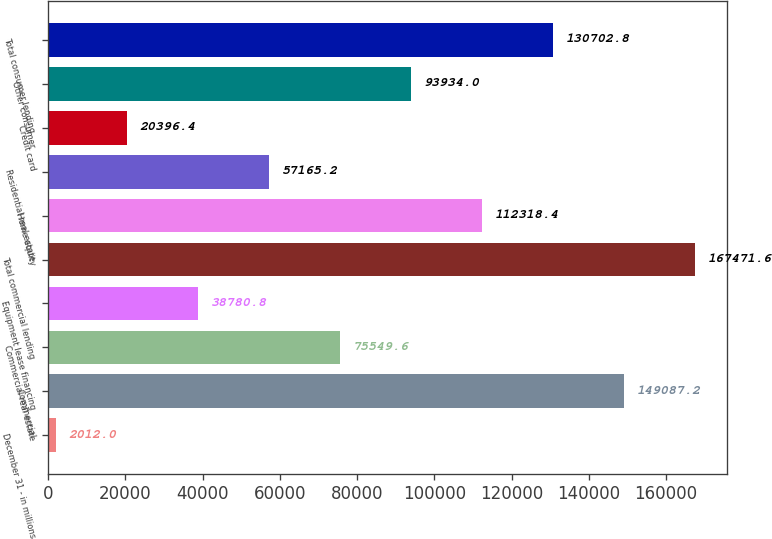<chart> <loc_0><loc_0><loc_500><loc_500><bar_chart><fcel>December 31 - in millions<fcel>Commercial<fcel>Commercial real estate<fcel>Equipment lease financing<fcel>Total commercial lending<fcel>Home equity<fcel>Residential real estate<fcel>Credit card<fcel>Other consumer<fcel>Total consumer lending<nl><fcel>2012<fcel>149087<fcel>75549.6<fcel>38780.8<fcel>167472<fcel>112318<fcel>57165.2<fcel>20396.4<fcel>93934<fcel>130703<nl></chart> 